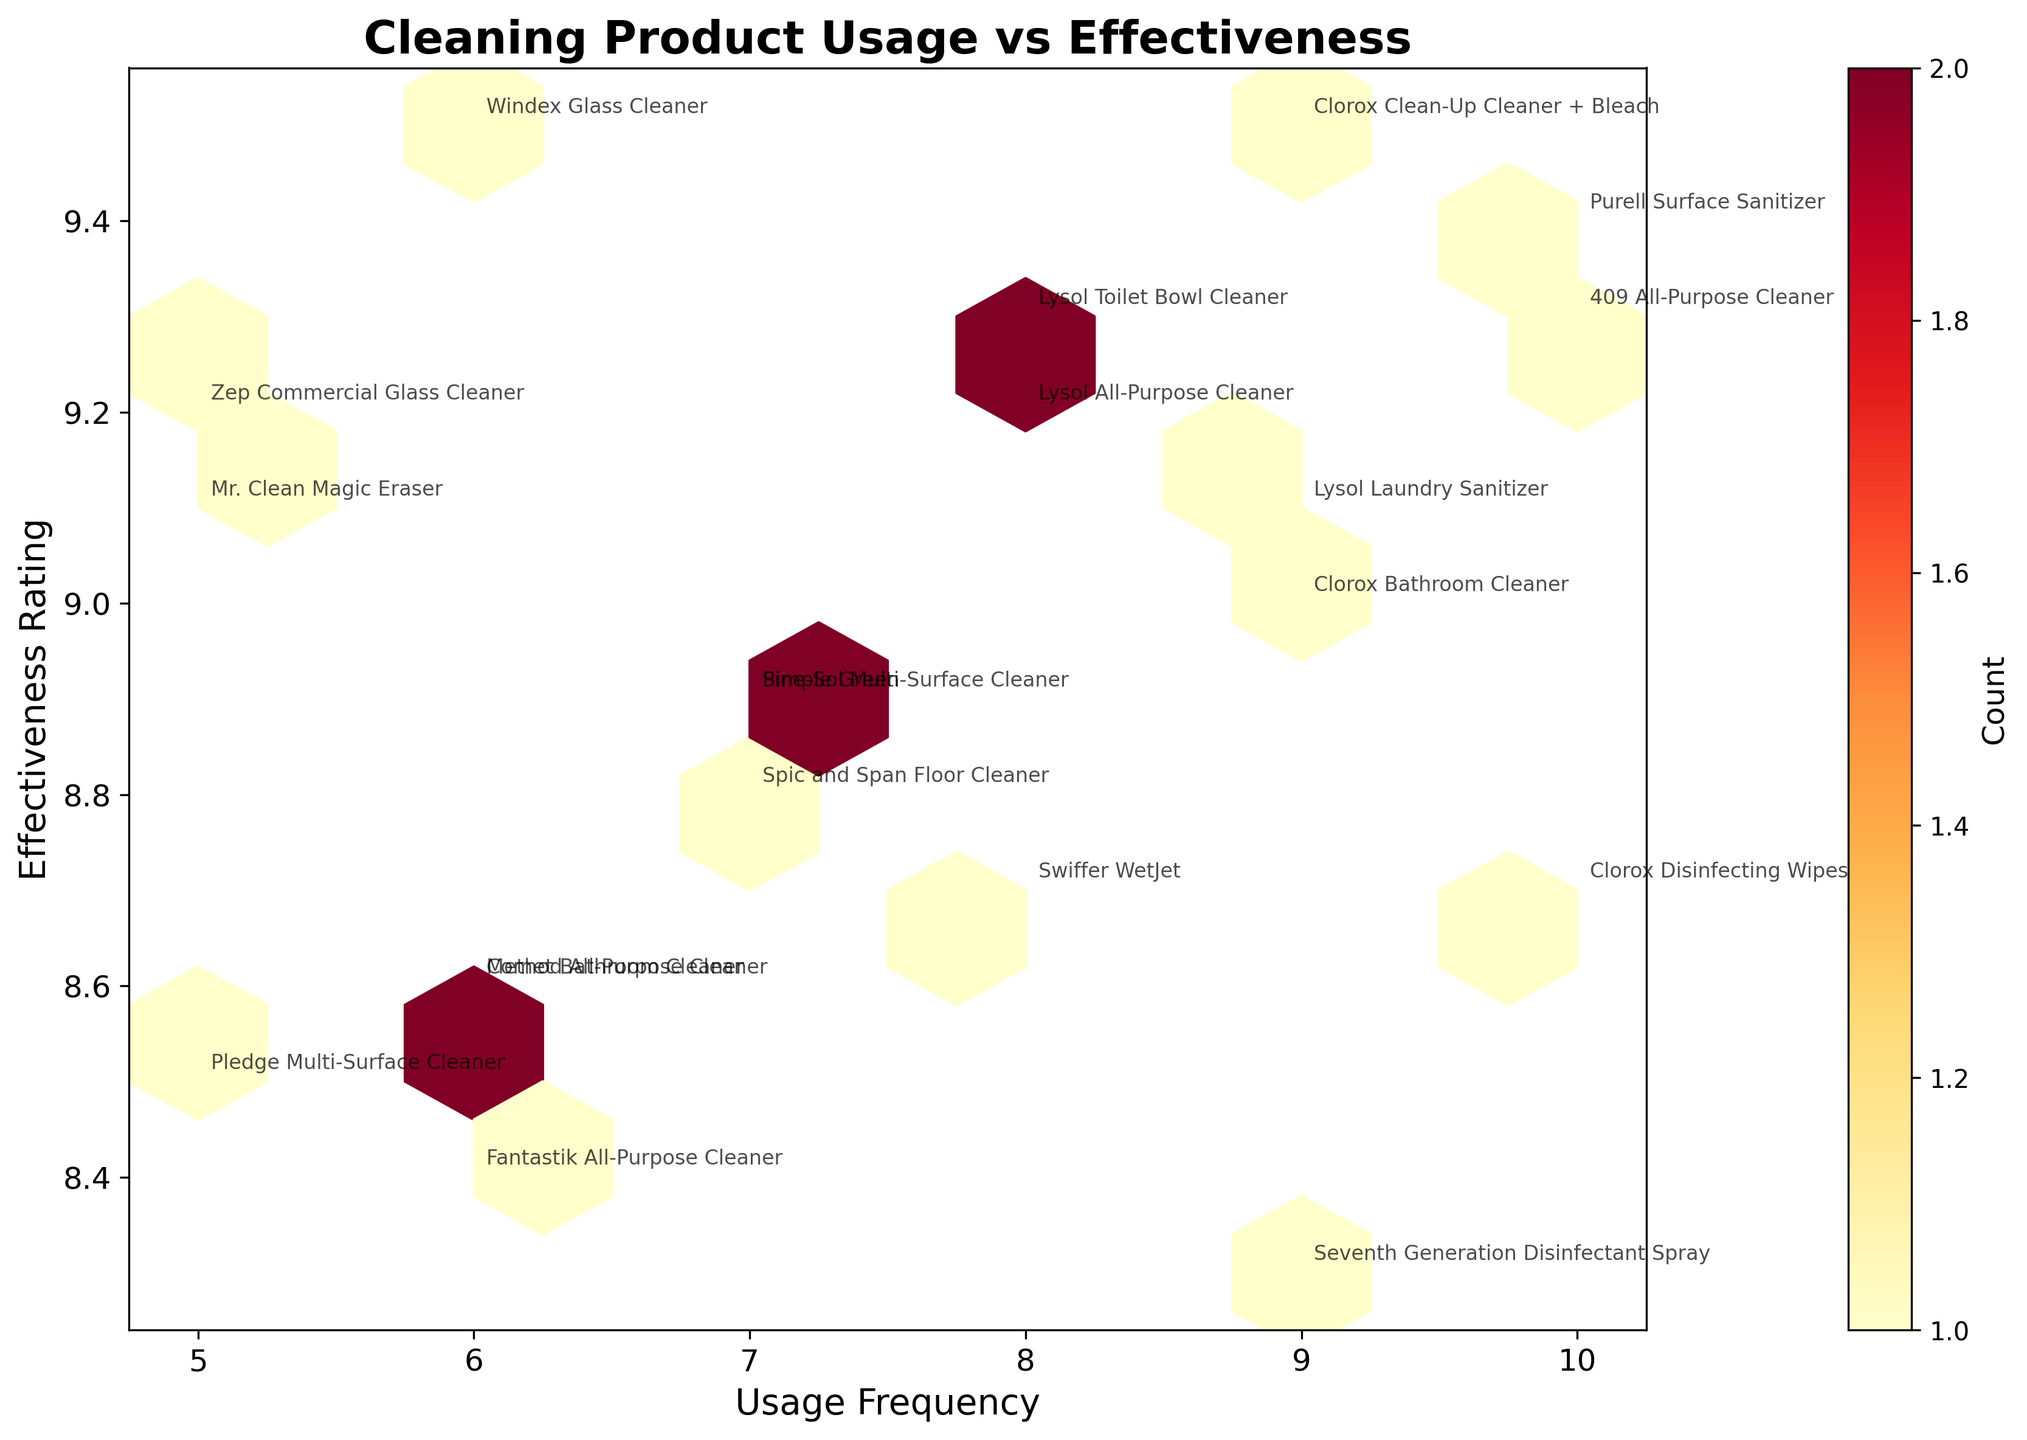What is the title of the hexbin plot? The title can be found at the top of the figure, which serves as a summary of the information being displayed. The title here is 'Cleaning Product Usage vs Effectiveness'.
Answer: Cleaning Product Usage vs Effectiveness What are the labels on the x-axis and y-axis? The labels of the axes describe what the data represents. On this hexbin plot, the x-axis is labeled 'Usage Frequency', and the y-axis is labeled 'Effectiveness Rating'.
Answer: Usage Frequency and Effectiveness Rating How many count bins are there? The number of count bins can be estimated by looking at the hexagons displayed on the plot. Each hexagon represents a bin containing the count of overlapping data points within it. By visually inspecting the plot or referring to the 'gridsize' parameter (although not exactly correct), we see there are 10 bins in each dimension.
Answer: 10x10 bins Which product appears to be used most frequently? The product with the highest usage frequency is identified by locating the point along the x-axis with the highest value. The highest x-value in the plot corresponds to 'Purell Surface Sanitizer' and '409 All-Purpose Cleaner' with a usage frequency of 10.
Answer: Purell Surface Sanitizer and 409 All-Purpose Cleaner Which product is rated highest in effectiveness? To find the product rated highest in effectiveness, look for the data point with the highest y-value. This corresponds to 'Windex Glass Cleaner' with an effectiveness rating of 9.5.
Answer: Windex Glass Cleaner What is the general trend between usage frequency and effectiveness rating? The general trend can be observed by noting the overall distribution of points. If points are concentrated evenly, there may not be a strong trend. In this plot, the points seem fairly spread, suggesting no strong correlation, positive or negative, between usage frequency and effectiveness rating.
Answer: No strong trend Are there any clusters or concentrations within certain areas of the plot? Clusters appear as darker or more densely filled hexagons. In this hexbin plot, there are noticeable concentrations around usage frequency 6 to 8 and effectiveness rating between 8.6 to 9.3.
Answer: Usage frequency 6-8, effectiveness rating 8.6-9.3 Which cleaning products fall into the highest density hexagon? The highest density hexagon can be identified by the darkest color within the plot. By observing the plot, cleaning products like 'Clorox Clean-Up Cleaner + Bleach', '409 All-Purpose Cleaner' and 'Purell Surface Sanitizer' fall into these densely packed areas.
Answer: Clorox Clean-Up Cleaner + Bleach, 409 All-Purpose Cleaner, Purell Surface Sanitizer How does the effectiveness rating of 'Method All-Purpose Cleaner' compare to 'Windex Glass Cleaner'? Comparing the positions of these two products on the y-axis, 'Windex Glass Cleaner' has a higher effectiveness rating (9.5) compared to 'Method All-Purpose Cleaner' (8.6).
Answer: Windex Glass Cleaner is higher Is there a product with an effectiveness rating that deviates significantly from others with similar usage frequency? To identify outliers, look for points that stand out noticeably from others around them. 'Windex Glass Cleaner' has a significantly higher effectiveness rating (9.5) compared to other products with similar usage frequencies (6).
Answer: Windex Glass Cleaner 